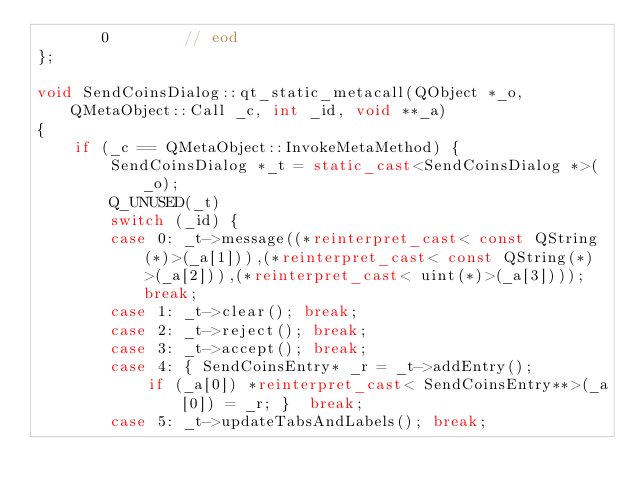Convert code to text. <code><loc_0><loc_0><loc_500><loc_500><_C++_>       0        // eod
};

void SendCoinsDialog::qt_static_metacall(QObject *_o, QMetaObject::Call _c, int _id, void **_a)
{
    if (_c == QMetaObject::InvokeMetaMethod) {
        SendCoinsDialog *_t = static_cast<SendCoinsDialog *>(_o);
        Q_UNUSED(_t)
        switch (_id) {
        case 0: _t->message((*reinterpret_cast< const QString(*)>(_a[1])),(*reinterpret_cast< const QString(*)>(_a[2])),(*reinterpret_cast< uint(*)>(_a[3]))); break;
        case 1: _t->clear(); break;
        case 2: _t->reject(); break;
        case 3: _t->accept(); break;
        case 4: { SendCoinsEntry* _r = _t->addEntry();
            if (_a[0]) *reinterpret_cast< SendCoinsEntry**>(_a[0]) = _r; }  break;
        case 5: _t->updateTabsAndLabels(); break;</code> 